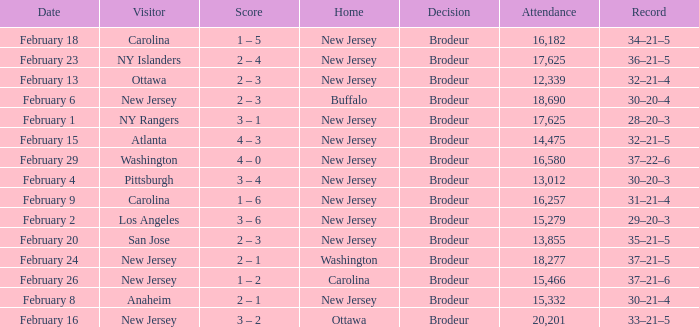What was the record when the visiting team was Ottawa? 32–21–4. 